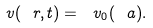Convert formula to latex. <formula><loc_0><loc_0><loc_500><loc_500>\ v ( \ r , t ) = \ v _ { 0 } ( \ a ) .</formula> 